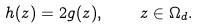<formula> <loc_0><loc_0><loc_500><loc_500>h ( z ) = 2 g ( z ) , \quad z \in \Omega _ { d } .</formula> 